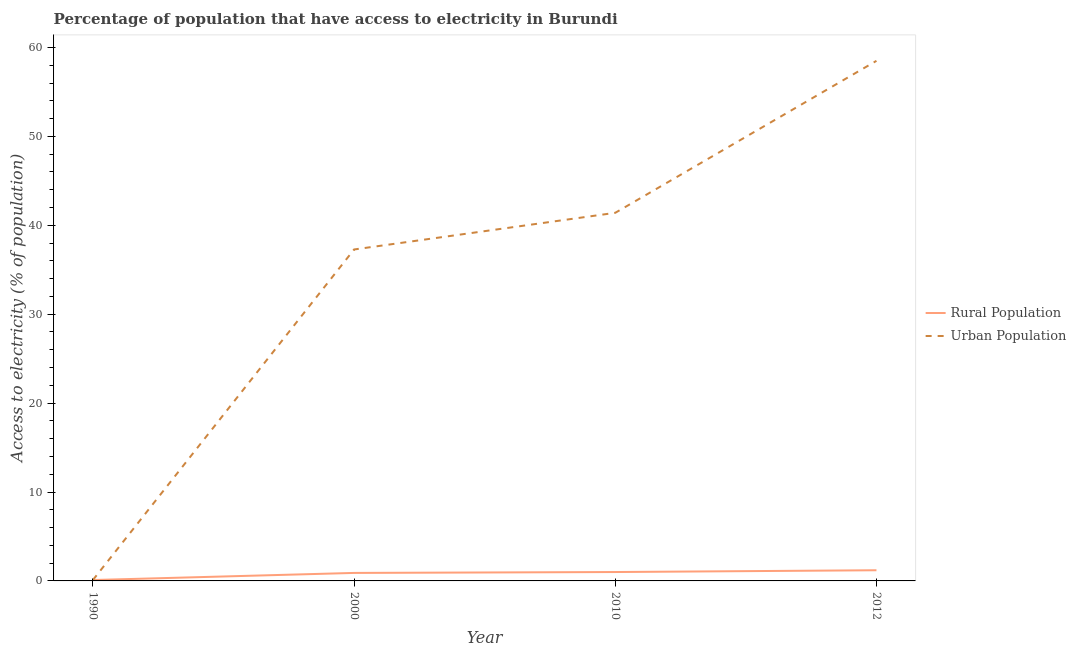Is the number of lines equal to the number of legend labels?
Give a very brief answer. Yes. What is the percentage of rural population having access to electricity in 1990?
Offer a terse response. 0.1. Across all years, what is the maximum percentage of urban population having access to electricity?
Offer a very short reply. 58.5. Across all years, what is the minimum percentage of urban population having access to electricity?
Keep it short and to the point. 0.1. In which year was the percentage of urban population having access to electricity maximum?
Your response must be concise. 2012. In which year was the percentage of rural population having access to electricity minimum?
Give a very brief answer. 1990. What is the total percentage of urban population having access to electricity in the graph?
Offer a very short reply. 137.29. What is the difference between the percentage of urban population having access to electricity in 2000 and that in 2012?
Offer a very short reply. -21.22. What is the average percentage of urban population having access to electricity per year?
Your response must be concise. 34.32. In the year 2000, what is the difference between the percentage of urban population having access to electricity and percentage of rural population having access to electricity?
Offer a terse response. 36.38. What is the ratio of the percentage of urban population having access to electricity in 1990 to that in 2012?
Keep it short and to the point. 0. Is the difference between the percentage of urban population having access to electricity in 2000 and 2010 greater than the difference between the percentage of rural population having access to electricity in 2000 and 2010?
Your answer should be compact. No. What is the difference between the highest and the second highest percentage of rural population having access to electricity?
Keep it short and to the point. 0.2. What is the difference between the highest and the lowest percentage of rural population having access to electricity?
Ensure brevity in your answer.  1.1. How many lines are there?
Your response must be concise. 2. Does the graph contain grids?
Offer a very short reply. No. Where does the legend appear in the graph?
Ensure brevity in your answer.  Center right. How many legend labels are there?
Offer a terse response. 2. What is the title of the graph?
Your answer should be compact. Percentage of population that have access to electricity in Burundi. Does "Old" appear as one of the legend labels in the graph?
Offer a very short reply. No. What is the label or title of the Y-axis?
Your answer should be very brief. Access to electricity (% of population). What is the Access to electricity (% of population) of Urban Population in 1990?
Provide a succinct answer. 0.1. What is the Access to electricity (% of population) in Urban Population in 2000?
Provide a succinct answer. 37.28. What is the Access to electricity (% of population) of Rural Population in 2010?
Your answer should be compact. 1. What is the Access to electricity (% of population) of Urban Population in 2010?
Ensure brevity in your answer.  41.41. What is the Access to electricity (% of population) in Urban Population in 2012?
Give a very brief answer. 58.5. Across all years, what is the maximum Access to electricity (% of population) in Urban Population?
Your answer should be compact. 58.5. Across all years, what is the minimum Access to electricity (% of population) of Rural Population?
Give a very brief answer. 0.1. Across all years, what is the minimum Access to electricity (% of population) in Urban Population?
Your answer should be compact. 0.1. What is the total Access to electricity (% of population) in Rural Population in the graph?
Your response must be concise. 3.2. What is the total Access to electricity (% of population) in Urban Population in the graph?
Provide a succinct answer. 137.29. What is the difference between the Access to electricity (% of population) in Rural Population in 1990 and that in 2000?
Your response must be concise. -0.8. What is the difference between the Access to electricity (% of population) in Urban Population in 1990 and that in 2000?
Make the answer very short. -37.18. What is the difference between the Access to electricity (% of population) of Urban Population in 1990 and that in 2010?
Your answer should be very brief. -41.31. What is the difference between the Access to electricity (% of population) in Rural Population in 1990 and that in 2012?
Offer a very short reply. -1.1. What is the difference between the Access to electricity (% of population) in Urban Population in 1990 and that in 2012?
Your answer should be very brief. -58.4. What is the difference between the Access to electricity (% of population) of Rural Population in 2000 and that in 2010?
Offer a very short reply. -0.1. What is the difference between the Access to electricity (% of population) in Urban Population in 2000 and that in 2010?
Offer a terse response. -4.12. What is the difference between the Access to electricity (% of population) of Urban Population in 2000 and that in 2012?
Offer a terse response. -21.22. What is the difference between the Access to electricity (% of population) of Urban Population in 2010 and that in 2012?
Offer a very short reply. -17.09. What is the difference between the Access to electricity (% of population) in Rural Population in 1990 and the Access to electricity (% of population) in Urban Population in 2000?
Make the answer very short. -37.18. What is the difference between the Access to electricity (% of population) of Rural Population in 1990 and the Access to electricity (% of population) of Urban Population in 2010?
Your response must be concise. -41.31. What is the difference between the Access to electricity (% of population) in Rural Population in 1990 and the Access to electricity (% of population) in Urban Population in 2012?
Offer a very short reply. -58.4. What is the difference between the Access to electricity (% of population) in Rural Population in 2000 and the Access to electricity (% of population) in Urban Population in 2010?
Ensure brevity in your answer.  -40.51. What is the difference between the Access to electricity (% of population) of Rural Population in 2000 and the Access to electricity (% of population) of Urban Population in 2012?
Your answer should be compact. -57.6. What is the difference between the Access to electricity (% of population) in Rural Population in 2010 and the Access to electricity (% of population) in Urban Population in 2012?
Your answer should be compact. -57.5. What is the average Access to electricity (% of population) of Rural Population per year?
Make the answer very short. 0.8. What is the average Access to electricity (% of population) of Urban Population per year?
Your answer should be compact. 34.32. In the year 1990, what is the difference between the Access to electricity (% of population) of Rural Population and Access to electricity (% of population) of Urban Population?
Provide a succinct answer. 0. In the year 2000, what is the difference between the Access to electricity (% of population) in Rural Population and Access to electricity (% of population) in Urban Population?
Your answer should be compact. -36.38. In the year 2010, what is the difference between the Access to electricity (% of population) in Rural Population and Access to electricity (% of population) in Urban Population?
Give a very brief answer. -40.41. In the year 2012, what is the difference between the Access to electricity (% of population) of Rural Population and Access to electricity (% of population) of Urban Population?
Give a very brief answer. -57.3. What is the ratio of the Access to electricity (% of population) of Rural Population in 1990 to that in 2000?
Offer a very short reply. 0.11. What is the ratio of the Access to electricity (% of population) of Urban Population in 1990 to that in 2000?
Your answer should be very brief. 0. What is the ratio of the Access to electricity (% of population) in Urban Population in 1990 to that in 2010?
Give a very brief answer. 0. What is the ratio of the Access to electricity (% of population) of Rural Population in 1990 to that in 2012?
Make the answer very short. 0.08. What is the ratio of the Access to electricity (% of population) in Urban Population in 1990 to that in 2012?
Offer a terse response. 0. What is the ratio of the Access to electricity (% of population) of Rural Population in 2000 to that in 2010?
Your answer should be compact. 0.9. What is the ratio of the Access to electricity (% of population) of Urban Population in 2000 to that in 2010?
Your response must be concise. 0.9. What is the ratio of the Access to electricity (% of population) in Urban Population in 2000 to that in 2012?
Make the answer very short. 0.64. What is the ratio of the Access to electricity (% of population) in Rural Population in 2010 to that in 2012?
Give a very brief answer. 0.83. What is the ratio of the Access to electricity (% of population) of Urban Population in 2010 to that in 2012?
Provide a succinct answer. 0.71. What is the difference between the highest and the second highest Access to electricity (% of population) of Rural Population?
Offer a terse response. 0.2. What is the difference between the highest and the second highest Access to electricity (% of population) of Urban Population?
Your response must be concise. 17.09. What is the difference between the highest and the lowest Access to electricity (% of population) of Rural Population?
Offer a very short reply. 1.1. What is the difference between the highest and the lowest Access to electricity (% of population) in Urban Population?
Offer a very short reply. 58.4. 